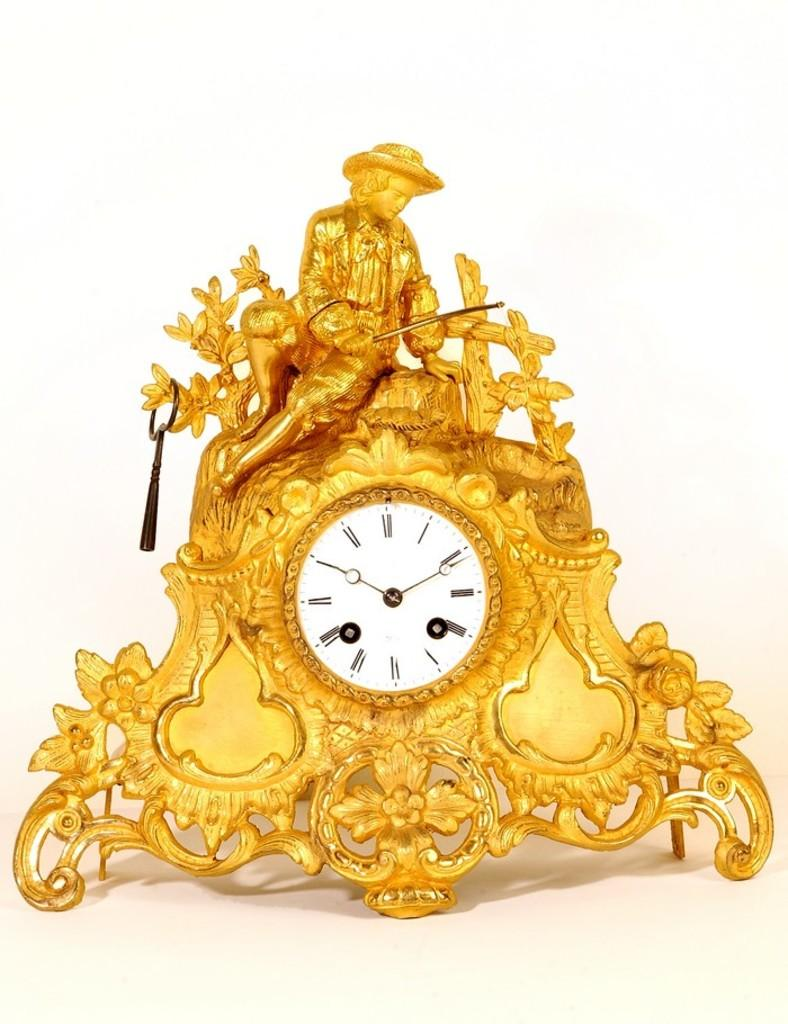<image>
Relay a brief, clear account of the picture shown. A golden clock with a fisherman on top reads the time as 2:50. 